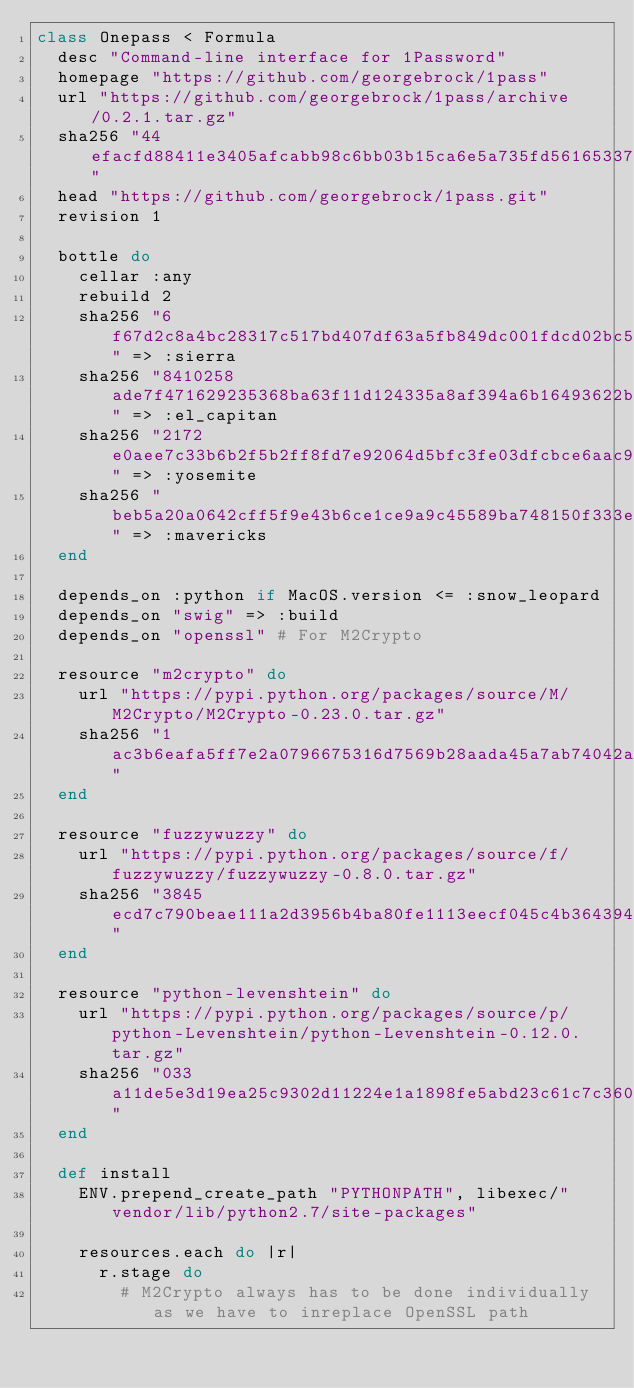<code> <loc_0><loc_0><loc_500><loc_500><_Ruby_>class Onepass < Formula
  desc "Command-line interface for 1Password"
  homepage "https://github.com/georgebrock/1pass"
  url "https://github.com/georgebrock/1pass/archive/0.2.1.tar.gz"
  sha256 "44efacfd88411e3405afcabb98c6bb03b15ca6e5a735fd561653379b880eb946"
  head "https://github.com/georgebrock/1pass.git"
  revision 1

  bottle do
    cellar :any
    rebuild 2
    sha256 "6f67d2c8a4bc28317c517bd407df63a5fb849dc001fdcd02bc5fdbe15d8d27af" => :sierra
    sha256 "8410258ade7f471629235368ba63f11d124335a8af394a6b16493622b3aac825" => :el_capitan
    sha256 "2172e0aee7c33b6b2f5b2ff8fd7e92064d5bfc3fe03dfcbce6aac9881f08e263" => :yosemite
    sha256 "beb5a20a0642cff5f9e43b6ce1ce9a9c45589ba748150f333e81a0c70090b7f2" => :mavericks
  end

  depends_on :python if MacOS.version <= :snow_leopard
  depends_on "swig" => :build
  depends_on "openssl" # For M2Crypto

  resource "m2crypto" do
    url "https://pypi.python.org/packages/source/M/M2Crypto/M2Crypto-0.23.0.tar.gz"
    sha256 "1ac3b6eafa5ff7e2a0796675316d7569b28aada45a7ab74042ad089d15a9567f"
  end

  resource "fuzzywuzzy" do
    url "https://pypi.python.org/packages/source/f/fuzzywuzzy/fuzzywuzzy-0.8.0.tar.gz"
    sha256 "3845ecd7c790beae111a2d3956b4ba80fe1113eecf045c4b364394eaa01ad9ce"
  end

  resource "python-levenshtein" do
    url "https://pypi.python.org/packages/source/p/python-Levenshtein/python-Levenshtein-0.12.0.tar.gz"
    sha256 "033a11de5e3d19ea25c9302d11224e1a1898fe5abd23c61c7c360c25195e3eb1"
  end

  def install
    ENV.prepend_create_path "PYTHONPATH", libexec/"vendor/lib/python2.7/site-packages"

    resources.each do |r|
      r.stage do
        # M2Crypto always has to be done individually as we have to inreplace OpenSSL path</code> 